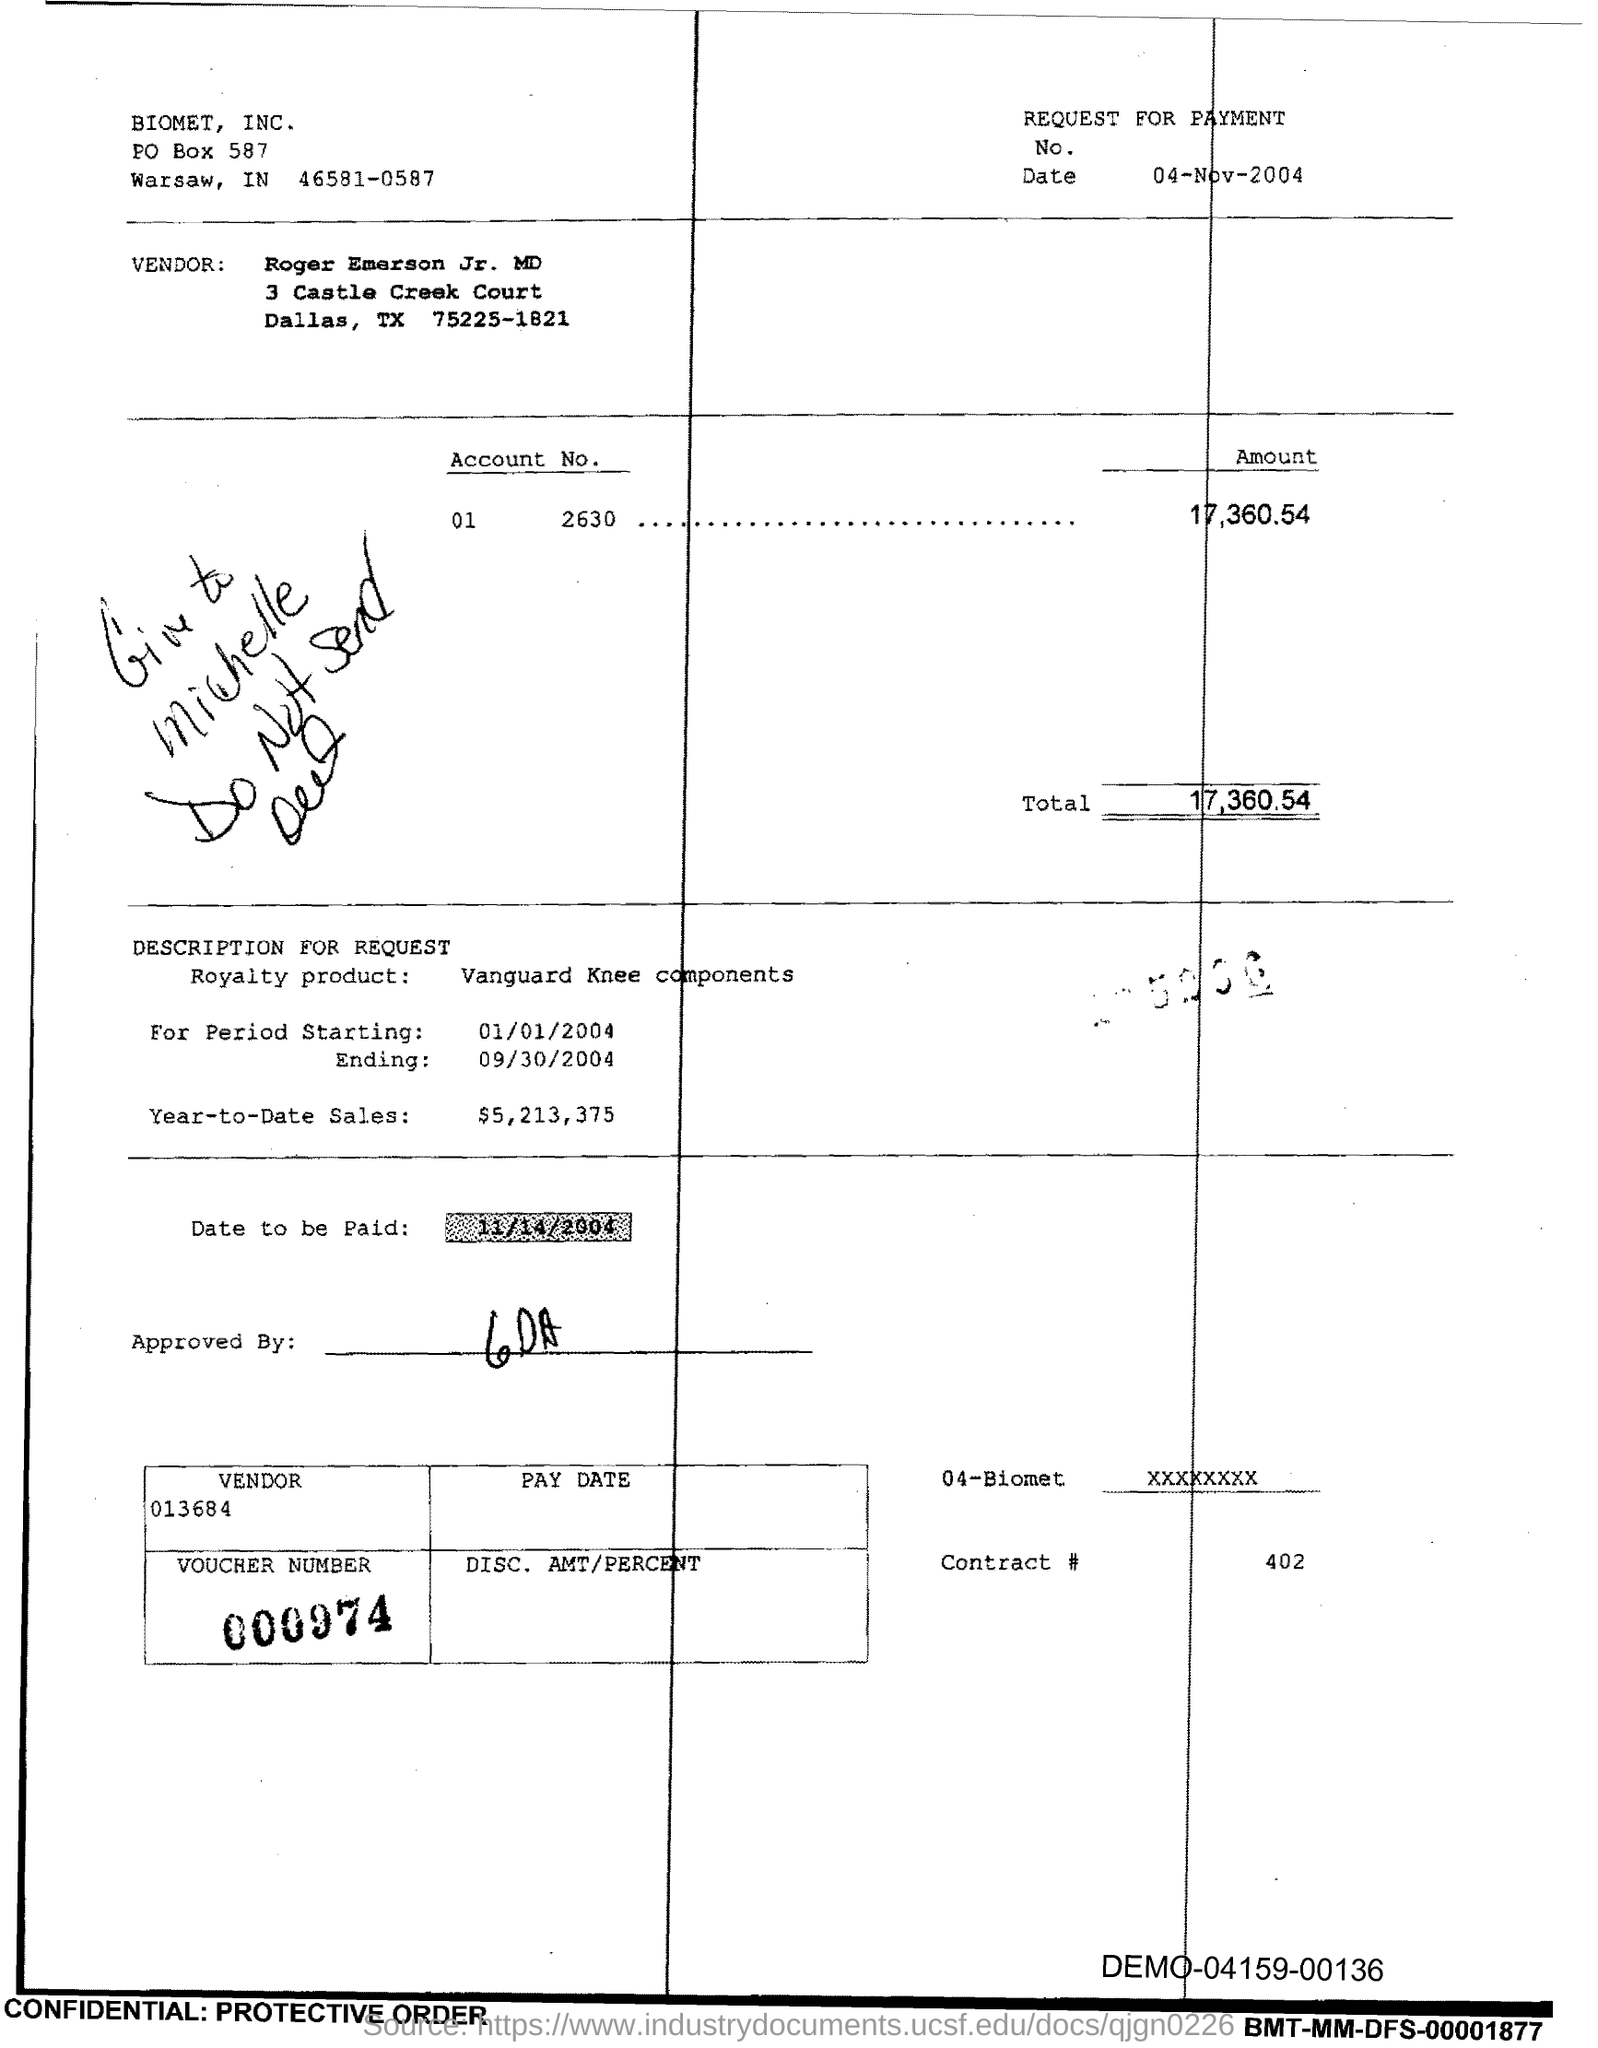What is the PO Box Number mentioned in the document?
Offer a terse response. 587. What is the Total?
Give a very brief answer. 17,360.54. What is the Contract # Number?
Your answer should be compact. 402. 